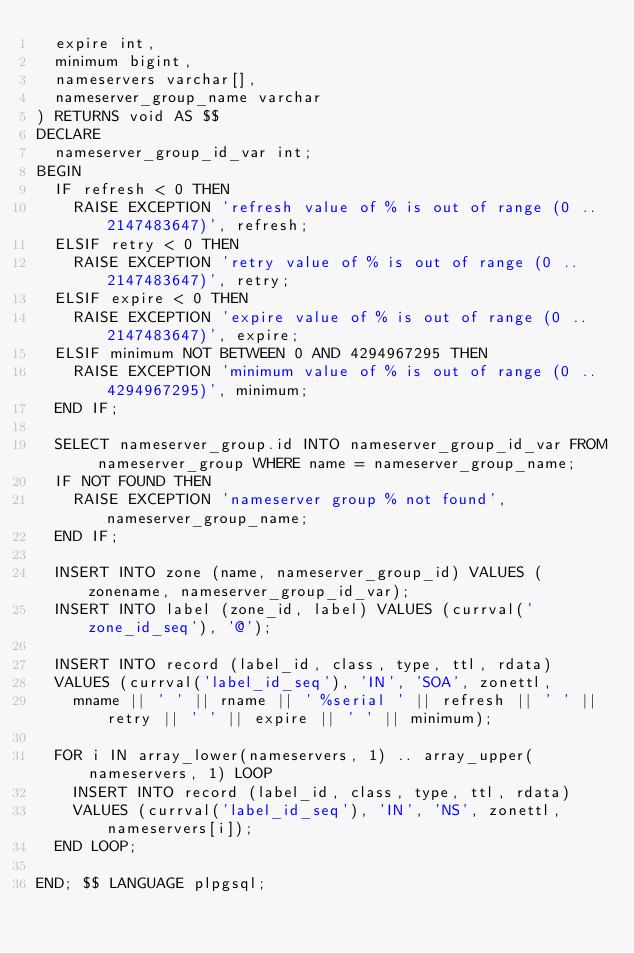<code> <loc_0><loc_0><loc_500><loc_500><_SQL_>	expire int,
	minimum bigint,
	nameservers varchar[],
	nameserver_group_name varchar
) RETURNS void AS $$
DECLARE
	nameserver_group_id_var int;
BEGIN
	IF refresh < 0 THEN
		RAISE EXCEPTION 'refresh value of % is out of range (0 .. 2147483647)', refresh;
	ELSIF retry < 0 THEN
		RAISE EXCEPTION 'retry value of % is out of range (0 .. 2147483647)', retry;
	ELSIF expire < 0 THEN
		RAISE EXCEPTION 'expire value of % is out of range (0 .. 2147483647)', expire;
	ELSIF minimum NOT BETWEEN 0 AND 4294967295 THEN 
		RAISE EXCEPTION 'minimum value of % is out of range (0 .. 4294967295)', minimum;
	END IF;

	SELECT nameserver_group.id INTO nameserver_group_id_var FROM nameserver_group WHERE name = nameserver_group_name;
	IF NOT FOUND THEN
		RAISE EXCEPTION 'nameserver group % not found', nameserver_group_name;
	END IF;

	INSERT INTO zone (name, nameserver_group_id) VALUES (zonename, nameserver_group_id_var);
	INSERT INTO label (zone_id, label) VALUES (currval('zone_id_seq'), '@');

	INSERT INTO record (label_id, class, type, ttl, rdata)
	VALUES (currval('label_id_seq'), 'IN', 'SOA', zonettl,
		mname || ' ' || rname || ' %serial ' || refresh || ' ' || retry || ' ' || expire || ' ' || minimum);

	FOR i IN array_lower(nameservers, 1) .. array_upper(nameservers, 1) LOOP
		INSERT INTO record (label_id, class, type, ttl, rdata)
		VALUES (currval('label_id_seq'), 'IN', 'NS', zonettl, nameservers[i]);
	END LOOP;

END; $$ LANGUAGE plpgsql;
</code> 